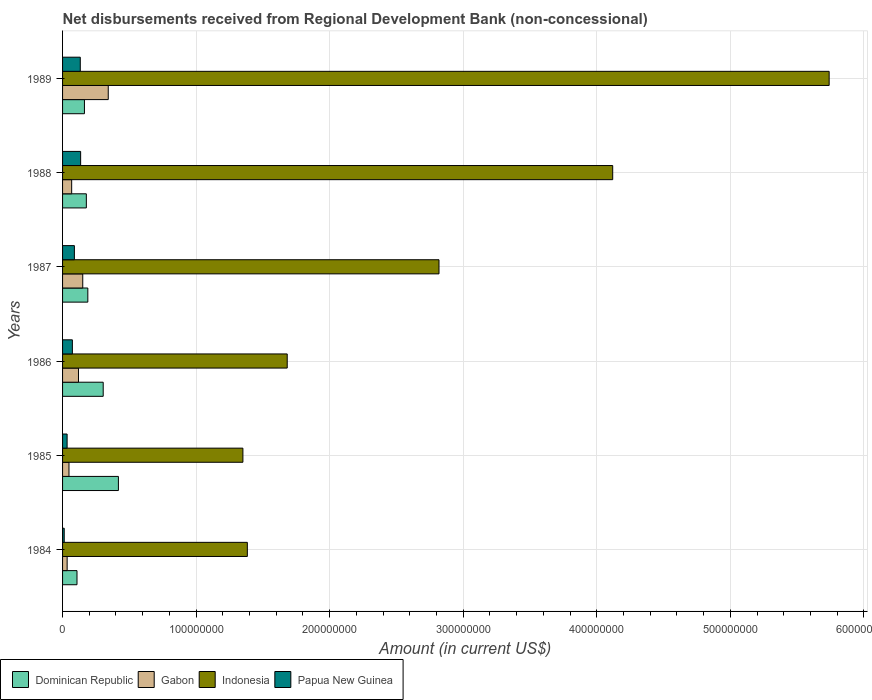How many bars are there on the 1st tick from the top?
Your answer should be compact. 4. How many bars are there on the 1st tick from the bottom?
Your response must be concise. 4. What is the label of the 2nd group of bars from the top?
Your answer should be compact. 1988. What is the amount of disbursements received from Regional Development Bank in Papua New Guinea in 1986?
Your response must be concise. 7.35e+06. Across all years, what is the maximum amount of disbursements received from Regional Development Bank in Dominican Republic?
Ensure brevity in your answer.  4.18e+07. Across all years, what is the minimum amount of disbursements received from Regional Development Bank in Indonesia?
Make the answer very short. 1.35e+08. What is the total amount of disbursements received from Regional Development Bank in Dominican Republic in the graph?
Keep it short and to the point. 1.36e+08. What is the difference between the amount of disbursements received from Regional Development Bank in Dominican Republic in 1985 and that in 1986?
Your answer should be compact. 1.14e+07. What is the difference between the amount of disbursements received from Regional Development Bank in Papua New Guinea in 1987 and the amount of disbursements received from Regional Development Bank in Dominican Republic in 1988?
Provide a succinct answer. -8.96e+06. What is the average amount of disbursements received from Regional Development Bank in Gabon per year?
Your response must be concise. 1.27e+07. In the year 1988, what is the difference between the amount of disbursements received from Regional Development Bank in Gabon and amount of disbursements received from Regional Development Bank in Papua New Guinea?
Give a very brief answer. -6.71e+06. In how many years, is the amount of disbursements received from Regional Development Bank in Dominican Republic greater than 340000000 US$?
Provide a succinct answer. 0. What is the ratio of the amount of disbursements received from Regional Development Bank in Papua New Guinea in 1986 to that in 1989?
Your answer should be very brief. 0.55. What is the difference between the highest and the second highest amount of disbursements received from Regional Development Bank in Gabon?
Provide a succinct answer. 1.91e+07. What is the difference between the highest and the lowest amount of disbursements received from Regional Development Bank in Dominican Republic?
Make the answer very short. 3.10e+07. Is the sum of the amount of disbursements received from Regional Development Bank in Papua New Guinea in 1987 and 1989 greater than the maximum amount of disbursements received from Regional Development Bank in Indonesia across all years?
Keep it short and to the point. No. What does the 4th bar from the top in 1986 represents?
Ensure brevity in your answer.  Dominican Republic. Is it the case that in every year, the sum of the amount of disbursements received from Regional Development Bank in Dominican Republic and amount of disbursements received from Regional Development Bank in Papua New Guinea is greater than the amount of disbursements received from Regional Development Bank in Gabon?
Make the answer very short. No. How many bars are there?
Offer a terse response. 24. How many years are there in the graph?
Provide a short and direct response. 6. Does the graph contain any zero values?
Your answer should be very brief. No. Does the graph contain grids?
Your answer should be very brief. Yes. How many legend labels are there?
Offer a very short reply. 4. How are the legend labels stacked?
Give a very brief answer. Horizontal. What is the title of the graph?
Give a very brief answer. Net disbursements received from Regional Development Bank (non-concessional). What is the label or title of the Y-axis?
Your response must be concise. Years. What is the Amount (in current US$) of Dominican Republic in 1984?
Your answer should be compact. 1.08e+07. What is the Amount (in current US$) of Gabon in 1984?
Offer a terse response. 3.42e+06. What is the Amount (in current US$) of Indonesia in 1984?
Provide a succinct answer. 1.38e+08. What is the Amount (in current US$) in Papua New Guinea in 1984?
Keep it short and to the point. 1.24e+06. What is the Amount (in current US$) in Dominican Republic in 1985?
Your response must be concise. 4.18e+07. What is the Amount (in current US$) in Gabon in 1985?
Your response must be concise. 4.81e+06. What is the Amount (in current US$) of Indonesia in 1985?
Your answer should be very brief. 1.35e+08. What is the Amount (in current US$) in Papua New Guinea in 1985?
Ensure brevity in your answer.  3.40e+06. What is the Amount (in current US$) in Dominican Republic in 1986?
Ensure brevity in your answer.  3.04e+07. What is the Amount (in current US$) in Gabon in 1986?
Offer a very short reply. 1.19e+07. What is the Amount (in current US$) of Indonesia in 1986?
Your answer should be very brief. 1.68e+08. What is the Amount (in current US$) of Papua New Guinea in 1986?
Provide a short and direct response. 7.35e+06. What is the Amount (in current US$) in Dominican Republic in 1987?
Offer a terse response. 1.89e+07. What is the Amount (in current US$) in Gabon in 1987?
Offer a very short reply. 1.51e+07. What is the Amount (in current US$) in Indonesia in 1987?
Ensure brevity in your answer.  2.82e+08. What is the Amount (in current US$) in Papua New Guinea in 1987?
Provide a short and direct response. 8.86e+06. What is the Amount (in current US$) in Dominican Republic in 1988?
Provide a short and direct response. 1.78e+07. What is the Amount (in current US$) of Gabon in 1988?
Offer a very short reply. 6.82e+06. What is the Amount (in current US$) of Indonesia in 1988?
Give a very brief answer. 4.12e+08. What is the Amount (in current US$) in Papua New Guinea in 1988?
Your response must be concise. 1.35e+07. What is the Amount (in current US$) in Dominican Republic in 1989?
Provide a short and direct response. 1.64e+07. What is the Amount (in current US$) of Gabon in 1989?
Keep it short and to the point. 3.42e+07. What is the Amount (in current US$) of Indonesia in 1989?
Your answer should be compact. 5.74e+08. What is the Amount (in current US$) in Papua New Guinea in 1989?
Make the answer very short. 1.33e+07. Across all years, what is the maximum Amount (in current US$) in Dominican Republic?
Give a very brief answer. 4.18e+07. Across all years, what is the maximum Amount (in current US$) in Gabon?
Give a very brief answer. 3.42e+07. Across all years, what is the maximum Amount (in current US$) of Indonesia?
Give a very brief answer. 5.74e+08. Across all years, what is the maximum Amount (in current US$) in Papua New Guinea?
Your response must be concise. 1.35e+07. Across all years, what is the minimum Amount (in current US$) in Dominican Republic?
Provide a succinct answer. 1.08e+07. Across all years, what is the minimum Amount (in current US$) in Gabon?
Offer a very short reply. 3.42e+06. Across all years, what is the minimum Amount (in current US$) in Indonesia?
Your response must be concise. 1.35e+08. Across all years, what is the minimum Amount (in current US$) of Papua New Guinea?
Provide a short and direct response. 1.24e+06. What is the total Amount (in current US$) in Dominican Republic in the graph?
Offer a terse response. 1.36e+08. What is the total Amount (in current US$) of Gabon in the graph?
Offer a very short reply. 7.63e+07. What is the total Amount (in current US$) of Indonesia in the graph?
Provide a succinct answer. 1.71e+09. What is the total Amount (in current US$) of Papua New Guinea in the graph?
Make the answer very short. 4.76e+07. What is the difference between the Amount (in current US$) in Dominican Republic in 1984 and that in 1985?
Offer a terse response. -3.10e+07. What is the difference between the Amount (in current US$) in Gabon in 1984 and that in 1985?
Ensure brevity in your answer.  -1.39e+06. What is the difference between the Amount (in current US$) of Indonesia in 1984 and that in 1985?
Give a very brief answer. 3.32e+06. What is the difference between the Amount (in current US$) of Papua New Guinea in 1984 and that in 1985?
Ensure brevity in your answer.  -2.16e+06. What is the difference between the Amount (in current US$) of Dominican Republic in 1984 and that in 1986?
Offer a very short reply. -1.96e+07. What is the difference between the Amount (in current US$) in Gabon in 1984 and that in 1986?
Your answer should be very brief. -8.49e+06. What is the difference between the Amount (in current US$) in Indonesia in 1984 and that in 1986?
Make the answer very short. -2.99e+07. What is the difference between the Amount (in current US$) of Papua New Guinea in 1984 and that in 1986?
Ensure brevity in your answer.  -6.11e+06. What is the difference between the Amount (in current US$) in Dominican Republic in 1984 and that in 1987?
Make the answer very short. -8.12e+06. What is the difference between the Amount (in current US$) in Gabon in 1984 and that in 1987?
Ensure brevity in your answer.  -1.17e+07. What is the difference between the Amount (in current US$) in Indonesia in 1984 and that in 1987?
Your response must be concise. -1.44e+08. What is the difference between the Amount (in current US$) of Papua New Guinea in 1984 and that in 1987?
Keep it short and to the point. -7.61e+06. What is the difference between the Amount (in current US$) of Dominican Republic in 1984 and that in 1988?
Give a very brief answer. -7.01e+06. What is the difference between the Amount (in current US$) of Gabon in 1984 and that in 1988?
Your response must be concise. -3.39e+06. What is the difference between the Amount (in current US$) in Indonesia in 1984 and that in 1988?
Provide a short and direct response. -2.74e+08. What is the difference between the Amount (in current US$) of Papua New Guinea in 1984 and that in 1988?
Your answer should be compact. -1.23e+07. What is the difference between the Amount (in current US$) in Dominican Republic in 1984 and that in 1989?
Your answer should be compact. -5.57e+06. What is the difference between the Amount (in current US$) of Gabon in 1984 and that in 1989?
Keep it short and to the point. -3.08e+07. What is the difference between the Amount (in current US$) in Indonesia in 1984 and that in 1989?
Offer a very short reply. -4.36e+08. What is the difference between the Amount (in current US$) of Papua New Guinea in 1984 and that in 1989?
Offer a terse response. -1.20e+07. What is the difference between the Amount (in current US$) in Dominican Republic in 1985 and that in 1986?
Your response must be concise. 1.14e+07. What is the difference between the Amount (in current US$) of Gabon in 1985 and that in 1986?
Offer a terse response. -7.11e+06. What is the difference between the Amount (in current US$) of Indonesia in 1985 and that in 1986?
Ensure brevity in your answer.  -3.32e+07. What is the difference between the Amount (in current US$) in Papua New Guinea in 1985 and that in 1986?
Keep it short and to the point. -3.94e+06. What is the difference between the Amount (in current US$) of Dominican Republic in 1985 and that in 1987?
Give a very brief answer. 2.29e+07. What is the difference between the Amount (in current US$) of Gabon in 1985 and that in 1987?
Keep it short and to the point. -1.03e+07. What is the difference between the Amount (in current US$) of Indonesia in 1985 and that in 1987?
Make the answer very short. -1.47e+08. What is the difference between the Amount (in current US$) in Papua New Guinea in 1985 and that in 1987?
Provide a succinct answer. -5.45e+06. What is the difference between the Amount (in current US$) in Dominican Republic in 1985 and that in 1988?
Keep it short and to the point. 2.40e+07. What is the difference between the Amount (in current US$) of Gabon in 1985 and that in 1988?
Give a very brief answer. -2.01e+06. What is the difference between the Amount (in current US$) in Indonesia in 1985 and that in 1988?
Provide a short and direct response. -2.77e+08. What is the difference between the Amount (in current US$) in Papua New Guinea in 1985 and that in 1988?
Offer a very short reply. -1.01e+07. What is the difference between the Amount (in current US$) in Dominican Republic in 1985 and that in 1989?
Keep it short and to the point. 2.54e+07. What is the difference between the Amount (in current US$) of Gabon in 1985 and that in 1989?
Offer a very short reply. -2.94e+07. What is the difference between the Amount (in current US$) in Indonesia in 1985 and that in 1989?
Give a very brief answer. -4.39e+08. What is the difference between the Amount (in current US$) of Papua New Guinea in 1985 and that in 1989?
Provide a short and direct response. -9.86e+06. What is the difference between the Amount (in current US$) in Dominican Republic in 1986 and that in 1987?
Make the answer very short. 1.15e+07. What is the difference between the Amount (in current US$) of Gabon in 1986 and that in 1987?
Keep it short and to the point. -3.20e+06. What is the difference between the Amount (in current US$) of Indonesia in 1986 and that in 1987?
Your answer should be compact. -1.14e+08. What is the difference between the Amount (in current US$) in Papua New Guinea in 1986 and that in 1987?
Ensure brevity in your answer.  -1.51e+06. What is the difference between the Amount (in current US$) in Dominican Republic in 1986 and that in 1988?
Give a very brief answer. 1.26e+07. What is the difference between the Amount (in current US$) in Gabon in 1986 and that in 1988?
Provide a short and direct response. 5.10e+06. What is the difference between the Amount (in current US$) of Indonesia in 1986 and that in 1988?
Make the answer very short. -2.44e+08. What is the difference between the Amount (in current US$) of Papua New Guinea in 1986 and that in 1988?
Offer a terse response. -6.18e+06. What is the difference between the Amount (in current US$) of Dominican Republic in 1986 and that in 1989?
Offer a very short reply. 1.40e+07. What is the difference between the Amount (in current US$) of Gabon in 1986 and that in 1989?
Give a very brief answer. -2.23e+07. What is the difference between the Amount (in current US$) in Indonesia in 1986 and that in 1989?
Your answer should be compact. -4.06e+08. What is the difference between the Amount (in current US$) of Papua New Guinea in 1986 and that in 1989?
Keep it short and to the point. -5.92e+06. What is the difference between the Amount (in current US$) in Dominican Republic in 1987 and that in 1988?
Offer a terse response. 1.11e+06. What is the difference between the Amount (in current US$) in Gabon in 1987 and that in 1988?
Keep it short and to the point. 8.30e+06. What is the difference between the Amount (in current US$) of Indonesia in 1987 and that in 1988?
Your answer should be compact. -1.30e+08. What is the difference between the Amount (in current US$) in Papua New Guinea in 1987 and that in 1988?
Keep it short and to the point. -4.68e+06. What is the difference between the Amount (in current US$) of Dominican Republic in 1987 and that in 1989?
Ensure brevity in your answer.  2.54e+06. What is the difference between the Amount (in current US$) of Gabon in 1987 and that in 1989?
Make the answer very short. -1.91e+07. What is the difference between the Amount (in current US$) of Indonesia in 1987 and that in 1989?
Your answer should be very brief. -2.92e+08. What is the difference between the Amount (in current US$) in Papua New Guinea in 1987 and that in 1989?
Give a very brief answer. -4.41e+06. What is the difference between the Amount (in current US$) of Dominican Republic in 1988 and that in 1989?
Ensure brevity in your answer.  1.43e+06. What is the difference between the Amount (in current US$) of Gabon in 1988 and that in 1989?
Your response must be concise. -2.74e+07. What is the difference between the Amount (in current US$) in Indonesia in 1988 and that in 1989?
Your response must be concise. -1.62e+08. What is the difference between the Amount (in current US$) of Papua New Guinea in 1988 and that in 1989?
Ensure brevity in your answer.  2.67e+05. What is the difference between the Amount (in current US$) in Dominican Republic in 1984 and the Amount (in current US$) in Gabon in 1985?
Your response must be concise. 5.99e+06. What is the difference between the Amount (in current US$) in Dominican Republic in 1984 and the Amount (in current US$) in Indonesia in 1985?
Give a very brief answer. -1.24e+08. What is the difference between the Amount (in current US$) in Dominican Republic in 1984 and the Amount (in current US$) in Papua New Guinea in 1985?
Provide a short and direct response. 7.40e+06. What is the difference between the Amount (in current US$) of Gabon in 1984 and the Amount (in current US$) of Indonesia in 1985?
Make the answer very short. -1.32e+08. What is the difference between the Amount (in current US$) in Gabon in 1984 and the Amount (in current US$) in Papua New Guinea in 1985?
Your response must be concise. 2.10e+04. What is the difference between the Amount (in current US$) of Indonesia in 1984 and the Amount (in current US$) of Papua New Guinea in 1985?
Your answer should be compact. 1.35e+08. What is the difference between the Amount (in current US$) in Dominican Republic in 1984 and the Amount (in current US$) in Gabon in 1986?
Your response must be concise. -1.12e+06. What is the difference between the Amount (in current US$) of Dominican Republic in 1984 and the Amount (in current US$) of Indonesia in 1986?
Give a very brief answer. -1.57e+08. What is the difference between the Amount (in current US$) in Dominican Republic in 1984 and the Amount (in current US$) in Papua New Guinea in 1986?
Make the answer very short. 3.46e+06. What is the difference between the Amount (in current US$) of Gabon in 1984 and the Amount (in current US$) of Indonesia in 1986?
Your answer should be compact. -1.65e+08. What is the difference between the Amount (in current US$) of Gabon in 1984 and the Amount (in current US$) of Papua New Guinea in 1986?
Your answer should be compact. -3.92e+06. What is the difference between the Amount (in current US$) of Indonesia in 1984 and the Amount (in current US$) of Papua New Guinea in 1986?
Your answer should be compact. 1.31e+08. What is the difference between the Amount (in current US$) in Dominican Republic in 1984 and the Amount (in current US$) in Gabon in 1987?
Your answer should be very brief. -4.32e+06. What is the difference between the Amount (in current US$) in Dominican Republic in 1984 and the Amount (in current US$) in Indonesia in 1987?
Your response must be concise. -2.71e+08. What is the difference between the Amount (in current US$) of Dominican Republic in 1984 and the Amount (in current US$) of Papua New Guinea in 1987?
Provide a short and direct response. 1.95e+06. What is the difference between the Amount (in current US$) of Gabon in 1984 and the Amount (in current US$) of Indonesia in 1987?
Your answer should be very brief. -2.78e+08. What is the difference between the Amount (in current US$) of Gabon in 1984 and the Amount (in current US$) of Papua New Guinea in 1987?
Provide a succinct answer. -5.43e+06. What is the difference between the Amount (in current US$) of Indonesia in 1984 and the Amount (in current US$) of Papua New Guinea in 1987?
Provide a short and direct response. 1.30e+08. What is the difference between the Amount (in current US$) of Dominican Republic in 1984 and the Amount (in current US$) of Gabon in 1988?
Your answer should be very brief. 3.98e+06. What is the difference between the Amount (in current US$) in Dominican Republic in 1984 and the Amount (in current US$) in Indonesia in 1988?
Provide a short and direct response. -4.01e+08. What is the difference between the Amount (in current US$) of Dominican Republic in 1984 and the Amount (in current US$) of Papua New Guinea in 1988?
Offer a very short reply. -2.73e+06. What is the difference between the Amount (in current US$) in Gabon in 1984 and the Amount (in current US$) in Indonesia in 1988?
Ensure brevity in your answer.  -4.09e+08. What is the difference between the Amount (in current US$) of Gabon in 1984 and the Amount (in current US$) of Papua New Guinea in 1988?
Offer a terse response. -1.01e+07. What is the difference between the Amount (in current US$) of Indonesia in 1984 and the Amount (in current US$) of Papua New Guinea in 1988?
Make the answer very short. 1.25e+08. What is the difference between the Amount (in current US$) of Dominican Republic in 1984 and the Amount (in current US$) of Gabon in 1989?
Ensure brevity in your answer.  -2.34e+07. What is the difference between the Amount (in current US$) in Dominican Republic in 1984 and the Amount (in current US$) in Indonesia in 1989?
Keep it short and to the point. -5.63e+08. What is the difference between the Amount (in current US$) in Dominican Republic in 1984 and the Amount (in current US$) in Papua New Guinea in 1989?
Provide a short and direct response. -2.46e+06. What is the difference between the Amount (in current US$) of Gabon in 1984 and the Amount (in current US$) of Indonesia in 1989?
Your response must be concise. -5.71e+08. What is the difference between the Amount (in current US$) of Gabon in 1984 and the Amount (in current US$) of Papua New Guinea in 1989?
Keep it short and to the point. -9.84e+06. What is the difference between the Amount (in current US$) of Indonesia in 1984 and the Amount (in current US$) of Papua New Guinea in 1989?
Offer a terse response. 1.25e+08. What is the difference between the Amount (in current US$) in Dominican Republic in 1985 and the Amount (in current US$) in Gabon in 1986?
Your response must be concise. 2.99e+07. What is the difference between the Amount (in current US$) of Dominican Republic in 1985 and the Amount (in current US$) of Indonesia in 1986?
Ensure brevity in your answer.  -1.26e+08. What is the difference between the Amount (in current US$) in Dominican Republic in 1985 and the Amount (in current US$) in Papua New Guinea in 1986?
Make the answer very short. 3.45e+07. What is the difference between the Amount (in current US$) of Gabon in 1985 and the Amount (in current US$) of Indonesia in 1986?
Make the answer very short. -1.63e+08. What is the difference between the Amount (in current US$) of Gabon in 1985 and the Amount (in current US$) of Papua New Guinea in 1986?
Ensure brevity in your answer.  -2.54e+06. What is the difference between the Amount (in current US$) of Indonesia in 1985 and the Amount (in current US$) of Papua New Guinea in 1986?
Offer a very short reply. 1.28e+08. What is the difference between the Amount (in current US$) of Dominican Republic in 1985 and the Amount (in current US$) of Gabon in 1987?
Ensure brevity in your answer.  2.67e+07. What is the difference between the Amount (in current US$) in Dominican Republic in 1985 and the Amount (in current US$) in Indonesia in 1987?
Offer a very short reply. -2.40e+08. What is the difference between the Amount (in current US$) in Dominican Republic in 1985 and the Amount (in current US$) in Papua New Guinea in 1987?
Give a very brief answer. 3.30e+07. What is the difference between the Amount (in current US$) in Gabon in 1985 and the Amount (in current US$) in Indonesia in 1987?
Your response must be concise. -2.77e+08. What is the difference between the Amount (in current US$) of Gabon in 1985 and the Amount (in current US$) of Papua New Guinea in 1987?
Your answer should be very brief. -4.04e+06. What is the difference between the Amount (in current US$) in Indonesia in 1985 and the Amount (in current US$) in Papua New Guinea in 1987?
Make the answer very short. 1.26e+08. What is the difference between the Amount (in current US$) of Dominican Republic in 1985 and the Amount (in current US$) of Gabon in 1988?
Your answer should be compact. 3.50e+07. What is the difference between the Amount (in current US$) in Dominican Republic in 1985 and the Amount (in current US$) in Indonesia in 1988?
Your answer should be compact. -3.70e+08. What is the difference between the Amount (in current US$) of Dominican Republic in 1985 and the Amount (in current US$) of Papua New Guinea in 1988?
Make the answer very short. 2.83e+07. What is the difference between the Amount (in current US$) in Gabon in 1985 and the Amount (in current US$) in Indonesia in 1988?
Your answer should be very brief. -4.07e+08. What is the difference between the Amount (in current US$) of Gabon in 1985 and the Amount (in current US$) of Papua New Guinea in 1988?
Ensure brevity in your answer.  -8.72e+06. What is the difference between the Amount (in current US$) in Indonesia in 1985 and the Amount (in current US$) in Papua New Guinea in 1988?
Your answer should be compact. 1.22e+08. What is the difference between the Amount (in current US$) in Dominican Republic in 1985 and the Amount (in current US$) in Gabon in 1989?
Make the answer very short. 7.61e+06. What is the difference between the Amount (in current US$) of Dominican Republic in 1985 and the Amount (in current US$) of Indonesia in 1989?
Provide a succinct answer. -5.32e+08. What is the difference between the Amount (in current US$) of Dominican Republic in 1985 and the Amount (in current US$) of Papua New Guinea in 1989?
Ensure brevity in your answer.  2.86e+07. What is the difference between the Amount (in current US$) in Gabon in 1985 and the Amount (in current US$) in Indonesia in 1989?
Provide a short and direct response. -5.69e+08. What is the difference between the Amount (in current US$) of Gabon in 1985 and the Amount (in current US$) of Papua New Guinea in 1989?
Your response must be concise. -8.45e+06. What is the difference between the Amount (in current US$) in Indonesia in 1985 and the Amount (in current US$) in Papua New Guinea in 1989?
Keep it short and to the point. 1.22e+08. What is the difference between the Amount (in current US$) in Dominican Republic in 1986 and the Amount (in current US$) in Gabon in 1987?
Offer a very short reply. 1.53e+07. What is the difference between the Amount (in current US$) in Dominican Republic in 1986 and the Amount (in current US$) in Indonesia in 1987?
Make the answer very short. -2.51e+08. What is the difference between the Amount (in current US$) of Dominican Republic in 1986 and the Amount (in current US$) of Papua New Guinea in 1987?
Offer a terse response. 2.16e+07. What is the difference between the Amount (in current US$) of Gabon in 1986 and the Amount (in current US$) of Indonesia in 1987?
Offer a terse response. -2.70e+08. What is the difference between the Amount (in current US$) of Gabon in 1986 and the Amount (in current US$) of Papua New Guinea in 1987?
Ensure brevity in your answer.  3.06e+06. What is the difference between the Amount (in current US$) in Indonesia in 1986 and the Amount (in current US$) in Papua New Guinea in 1987?
Provide a succinct answer. 1.59e+08. What is the difference between the Amount (in current US$) in Dominican Republic in 1986 and the Amount (in current US$) in Gabon in 1988?
Ensure brevity in your answer.  2.36e+07. What is the difference between the Amount (in current US$) in Dominican Republic in 1986 and the Amount (in current US$) in Indonesia in 1988?
Provide a succinct answer. -3.82e+08. What is the difference between the Amount (in current US$) of Dominican Republic in 1986 and the Amount (in current US$) of Papua New Guinea in 1988?
Your answer should be very brief. 1.69e+07. What is the difference between the Amount (in current US$) of Gabon in 1986 and the Amount (in current US$) of Indonesia in 1988?
Keep it short and to the point. -4.00e+08. What is the difference between the Amount (in current US$) of Gabon in 1986 and the Amount (in current US$) of Papua New Guinea in 1988?
Give a very brief answer. -1.61e+06. What is the difference between the Amount (in current US$) in Indonesia in 1986 and the Amount (in current US$) in Papua New Guinea in 1988?
Provide a succinct answer. 1.55e+08. What is the difference between the Amount (in current US$) of Dominican Republic in 1986 and the Amount (in current US$) of Gabon in 1989?
Provide a succinct answer. -3.79e+06. What is the difference between the Amount (in current US$) of Dominican Republic in 1986 and the Amount (in current US$) of Indonesia in 1989?
Offer a very short reply. -5.44e+08. What is the difference between the Amount (in current US$) in Dominican Republic in 1986 and the Amount (in current US$) in Papua New Guinea in 1989?
Offer a very short reply. 1.72e+07. What is the difference between the Amount (in current US$) of Gabon in 1986 and the Amount (in current US$) of Indonesia in 1989?
Provide a short and direct response. -5.62e+08. What is the difference between the Amount (in current US$) in Gabon in 1986 and the Amount (in current US$) in Papua New Guinea in 1989?
Offer a very short reply. -1.35e+06. What is the difference between the Amount (in current US$) of Indonesia in 1986 and the Amount (in current US$) of Papua New Guinea in 1989?
Ensure brevity in your answer.  1.55e+08. What is the difference between the Amount (in current US$) of Dominican Republic in 1987 and the Amount (in current US$) of Gabon in 1988?
Provide a short and direct response. 1.21e+07. What is the difference between the Amount (in current US$) of Dominican Republic in 1987 and the Amount (in current US$) of Indonesia in 1988?
Your response must be concise. -3.93e+08. What is the difference between the Amount (in current US$) in Dominican Republic in 1987 and the Amount (in current US$) in Papua New Guinea in 1988?
Your answer should be compact. 5.39e+06. What is the difference between the Amount (in current US$) of Gabon in 1987 and the Amount (in current US$) of Indonesia in 1988?
Your response must be concise. -3.97e+08. What is the difference between the Amount (in current US$) in Gabon in 1987 and the Amount (in current US$) in Papua New Guinea in 1988?
Keep it short and to the point. 1.59e+06. What is the difference between the Amount (in current US$) of Indonesia in 1987 and the Amount (in current US$) of Papua New Guinea in 1988?
Your answer should be compact. 2.68e+08. What is the difference between the Amount (in current US$) of Dominican Republic in 1987 and the Amount (in current US$) of Gabon in 1989?
Keep it short and to the point. -1.53e+07. What is the difference between the Amount (in current US$) of Dominican Republic in 1987 and the Amount (in current US$) of Indonesia in 1989?
Provide a succinct answer. -5.55e+08. What is the difference between the Amount (in current US$) in Dominican Republic in 1987 and the Amount (in current US$) in Papua New Guinea in 1989?
Provide a succinct answer. 5.66e+06. What is the difference between the Amount (in current US$) in Gabon in 1987 and the Amount (in current US$) in Indonesia in 1989?
Offer a very short reply. -5.59e+08. What is the difference between the Amount (in current US$) of Gabon in 1987 and the Amount (in current US$) of Papua New Guinea in 1989?
Make the answer very short. 1.85e+06. What is the difference between the Amount (in current US$) of Indonesia in 1987 and the Amount (in current US$) of Papua New Guinea in 1989?
Keep it short and to the point. 2.69e+08. What is the difference between the Amount (in current US$) in Dominican Republic in 1988 and the Amount (in current US$) in Gabon in 1989?
Offer a very short reply. -1.64e+07. What is the difference between the Amount (in current US$) in Dominican Republic in 1988 and the Amount (in current US$) in Indonesia in 1989?
Ensure brevity in your answer.  -5.56e+08. What is the difference between the Amount (in current US$) in Dominican Republic in 1988 and the Amount (in current US$) in Papua New Guinea in 1989?
Offer a terse response. 4.54e+06. What is the difference between the Amount (in current US$) of Gabon in 1988 and the Amount (in current US$) of Indonesia in 1989?
Provide a succinct answer. -5.67e+08. What is the difference between the Amount (in current US$) of Gabon in 1988 and the Amount (in current US$) of Papua New Guinea in 1989?
Ensure brevity in your answer.  -6.45e+06. What is the difference between the Amount (in current US$) of Indonesia in 1988 and the Amount (in current US$) of Papua New Guinea in 1989?
Give a very brief answer. 3.99e+08. What is the average Amount (in current US$) in Dominican Republic per year?
Keep it short and to the point. 2.27e+07. What is the average Amount (in current US$) of Gabon per year?
Keep it short and to the point. 1.27e+07. What is the average Amount (in current US$) of Indonesia per year?
Provide a short and direct response. 2.85e+08. What is the average Amount (in current US$) in Papua New Guinea per year?
Ensure brevity in your answer.  7.94e+06. In the year 1984, what is the difference between the Amount (in current US$) of Dominican Republic and Amount (in current US$) of Gabon?
Your response must be concise. 7.38e+06. In the year 1984, what is the difference between the Amount (in current US$) of Dominican Republic and Amount (in current US$) of Indonesia?
Your answer should be very brief. -1.28e+08. In the year 1984, what is the difference between the Amount (in current US$) of Dominican Republic and Amount (in current US$) of Papua New Guinea?
Provide a short and direct response. 9.56e+06. In the year 1984, what is the difference between the Amount (in current US$) in Gabon and Amount (in current US$) in Indonesia?
Your answer should be very brief. -1.35e+08. In the year 1984, what is the difference between the Amount (in current US$) in Gabon and Amount (in current US$) in Papua New Guinea?
Make the answer very short. 2.18e+06. In the year 1984, what is the difference between the Amount (in current US$) of Indonesia and Amount (in current US$) of Papua New Guinea?
Offer a terse response. 1.37e+08. In the year 1985, what is the difference between the Amount (in current US$) in Dominican Republic and Amount (in current US$) in Gabon?
Your answer should be compact. 3.70e+07. In the year 1985, what is the difference between the Amount (in current US$) of Dominican Republic and Amount (in current US$) of Indonesia?
Your answer should be very brief. -9.32e+07. In the year 1985, what is the difference between the Amount (in current US$) of Dominican Republic and Amount (in current US$) of Papua New Guinea?
Make the answer very short. 3.84e+07. In the year 1985, what is the difference between the Amount (in current US$) of Gabon and Amount (in current US$) of Indonesia?
Your answer should be compact. -1.30e+08. In the year 1985, what is the difference between the Amount (in current US$) of Gabon and Amount (in current US$) of Papua New Guinea?
Keep it short and to the point. 1.41e+06. In the year 1985, what is the difference between the Amount (in current US$) of Indonesia and Amount (in current US$) of Papua New Guinea?
Provide a short and direct response. 1.32e+08. In the year 1986, what is the difference between the Amount (in current US$) in Dominican Republic and Amount (in current US$) in Gabon?
Offer a very short reply. 1.85e+07. In the year 1986, what is the difference between the Amount (in current US$) in Dominican Republic and Amount (in current US$) in Indonesia?
Offer a terse response. -1.38e+08. In the year 1986, what is the difference between the Amount (in current US$) of Dominican Republic and Amount (in current US$) of Papua New Guinea?
Provide a succinct answer. 2.31e+07. In the year 1986, what is the difference between the Amount (in current US$) in Gabon and Amount (in current US$) in Indonesia?
Offer a very short reply. -1.56e+08. In the year 1986, what is the difference between the Amount (in current US$) of Gabon and Amount (in current US$) of Papua New Guinea?
Provide a short and direct response. 4.57e+06. In the year 1986, what is the difference between the Amount (in current US$) of Indonesia and Amount (in current US$) of Papua New Guinea?
Your answer should be very brief. 1.61e+08. In the year 1987, what is the difference between the Amount (in current US$) in Dominican Republic and Amount (in current US$) in Gabon?
Your answer should be compact. 3.80e+06. In the year 1987, what is the difference between the Amount (in current US$) of Dominican Republic and Amount (in current US$) of Indonesia?
Provide a succinct answer. -2.63e+08. In the year 1987, what is the difference between the Amount (in current US$) of Dominican Republic and Amount (in current US$) of Papua New Guinea?
Your response must be concise. 1.01e+07. In the year 1987, what is the difference between the Amount (in current US$) of Gabon and Amount (in current US$) of Indonesia?
Offer a very short reply. -2.67e+08. In the year 1987, what is the difference between the Amount (in current US$) of Gabon and Amount (in current US$) of Papua New Guinea?
Offer a very short reply. 6.26e+06. In the year 1987, what is the difference between the Amount (in current US$) of Indonesia and Amount (in current US$) of Papua New Guinea?
Ensure brevity in your answer.  2.73e+08. In the year 1988, what is the difference between the Amount (in current US$) in Dominican Republic and Amount (in current US$) in Gabon?
Provide a short and direct response. 1.10e+07. In the year 1988, what is the difference between the Amount (in current US$) of Dominican Republic and Amount (in current US$) of Indonesia?
Your answer should be compact. -3.94e+08. In the year 1988, what is the difference between the Amount (in current US$) in Dominican Republic and Amount (in current US$) in Papua New Guinea?
Provide a short and direct response. 4.28e+06. In the year 1988, what is the difference between the Amount (in current US$) in Gabon and Amount (in current US$) in Indonesia?
Ensure brevity in your answer.  -4.05e+08. In the year 1988, what is the difference between the Amount (in current US$) in Gabon and Amount (in current US$) in Papua New Guinea?
Make the answer very short. -6.71e+06. In the year 1988, what is the difference between the Amount (in current US$) in Indonesia and Amount (in current US$) in Papua New Guinea?
Give a very brief answer. 3.98e+08. In the year 1989, what is the difference between the Amount (in current US$) of Dominican Republic and Amount (in current US$) of Gabon?
Provide a short and direct response. -1.78e+07. In the year 1989, what is the difference between the Amount (in current US$) of Dominican Republic and Amount (in current US$) of Indonesia?
Your answer should be very brief. -5.58e+08. In the year 1989, what is the difference between the Amount (in current US$) in Dominican Republic and Amount (in current US$) in Papua New Guinea?
Your response must be concise. 3.11e+06. In the year 1989, what is the difference between the Amount (in current US$) in Gabon and Amount (in current US$) in Indonesia?
Your answer should be compact. -5.40e+08. In the year 1989, what is the difference between the Amount (in current US$) in Gabon and Amount (in current US$) in Papua New Guinea?
Your response must be concise. 2.09e+07. In the year 1989, what is the difference between the Amount (in current US$) of Indonesia and Amount (in current US$) of Papua New Guinea?
Keep it short and to the point. 5.61e+08. What is the ratio of the Amount (in current US$) of Dominican Republic in 1984 to that in 1985?
Ensure brevity in your answer.  0.26. What is the ratio of the Amount (in current US$) in Gabon in 1984 to that in 1985?
Your response must be concise. 0.71. What is the ratio of the Amount (in current US$) of Indonesia in 1984 to that in 1985?
Give a very brief answer. 1.02. What is the ratio of the Amount (in current US$) in Papua New Guinea in 1984 to that in 1985?
Your response must be concise. 0.36. What is the ratio of the Amount (in current US$) in Dominican Republic in 1984 to that in 1986?
Give a very brief answer. 0.36. What is the ratio of the Amount (in current US$) in Gabon in 1984 to that in 1986?
Provide a succinct answer. 0.29. What is the ratio of the Amount (in current US$) in Indonesia in 1984 to that in 1986?
Offer a very short reply. 0.82. What is the ratio of the Amount (in current US$) of Papua New Guinea in 1984 to that in 1986?
Give a very brief answer. 0.17. What is the ratio of the Amount (in current US$) of Dominican Republic in 1984 to that in 1987?
Your response must be concise. 0.57. What is the ratio of the Amount (in current US$) in Gabon in 1984 to that in 1987?
Keep it short and to the point. 0.23. What is the ratio of the Amount (in current US$) of Indonesia in 1984 to that in 1987?
Provide a short and direct response. 0.49. What is the ratio of the Amount (in current US$) of Papua New Guinea in 1984 to that in 1987?
Keep it short and to the point. 0.14. What is the ratio of the Amount (in current US$) in Dominican Republic in 1984 to that in 1988?
Offer a very short reply. 0.61. What is the ratio of the Amount (in current US$) in Gabon in 1984 to that in 1988?
Give a very brief answer. 0.5. What is the ratio of the Amount (in current US$) of Indonesia in 1984 to that in 1988?
Your response must be concise. 0.34. What is the ratio of the Amount (in current US$) of Papua New Guinea in 1984 to that in 1988?
Offer a terse response. 0.09. What is the ratio of the Amount (in current US$) of Dominican Republic in 1984 to that in 1989?
Give a very brief answer. 0.66. What is the ratio of the Amount (in current US$) of Gabon in 1984 to that in 1989?
Make the answer very short. 0.1. What is the ratio of the Amount (in current US$) in Indonesia in 1984 to that in 1989?
Ensure brevity in your answer.  0.24. What is the ratio of the Amount (in current US$) in Papua New Guinea in 1984 to that in 1989?
Your answer should be compact. 0.09. What is the ratio of the Amount (in current US$) of Dominican Republic in 1985 to that in 1986?
Give a very brief answer. 1.37. What is the ratio of the Amount (in current US$) in Gabon in 1985 to that in 1986?
Your answer should be very brief. 0.4. What is the ratio of the Amount (in current US$) of Indonesia in 1985 to that in 1986?
Your response must be concise. 0.8. What is the ratio of the Amount (in current US$) of Papua New Guinea in 1985 to that in 1986?
Provide a short and direct response. 0.46. What is the ratio of the Amount (in current US$) in Dominican Republic in 1985 to that in 1987?
Your answer should be very brief. 2.21. What is the ratio of the Amount (in current US$) in Gabon in 1985 to that in 1987?
Your answer should be compact. 0.32. What is the ratio of the Amount (in current US$) of Indonesia in 1985 to that in 1987?
Offer a very short reply. 0.48. What is the ratio of the Amount (in current US$) in Papua New Guinea in 1985 to that in 1987?
Offer a very short reply. 0.38. What is the ratio of the Amount (in current US$) of Dominican Republic in 1985 to that in 1988?
Ensure brevity in your answer.  2.35. What is the ratio of the Amount (in current US$) of Gabon in 1985 to that in 1988?
Your answer should be compact. 0.71. What is the ratio of the Amount (in current US$) of Indonesia in 1985 to that in 1988?
Your response must be concise. 0.33. What is the ratio of the Amount (in current US$) in Papua New Guinea in 1985 to that in 1988?
Keep it short and to the point. 0.25. What is the ratio of the Amount (in current US$) in Dominican Republic in 1985 to that in 1989?
Provide a short and direct response. 2.55. What is the ratio of the Amount (in current US$) of Gabon in 1985 to that in 1989?
Your answer should be compact. 0.14. What is the ratio of the Amount (in current US$) in Indonesia in 1985 to that in 1989?
Your answer should be very brief. 0.24. What is the ratio of the Amount (in current US$) of Papua New Guinea in 1985 to that in 1989?
Keep it short and to the point. 0.26. What is the ratio of the Amount (in current US$) in Dominican Republic in 1986 to that in 1987?
Make the answer very short. 1.61. What is the ratio of the Amount (in current US$) of Gabon in 1986 to that in 1987?
Your answer should be very brief. 0.79. What is the ratio of the Amount (in current US$) of Indonesia in 1986 to that in 1987?
Provide a succinct answer. 0.6. What is the ratio of the Amount (in current US$) of Papua New Guinea in 1986 to that in 1987?
Make the answer very short. 0.83. What is the ratio of the Amount (in current US$) in Dominican Republic in 1986 to that in 1988?
Ensure brevity in your answer.  1.71. What is the ratio of the Amount (in current US$) of Gabon in 1986 to that in 1988?
Make the answer very short. 1.75. What is the ratio of the Amount (in current US$) in Indonesia in 1986 to that in 1988?
Offer a very short reply. 0.41. What is the ratio of the Amount (in current US$) of Papua New Guinea in 1986 to that in 1988?
Ensure brevity in your answer.  0.54. What is the ratio of the Amount (in current US$) of Dominican Republic in 1986 to that in 1989?
Offer a terse response. 1.86. What is the ratio of the Amount (in current US$) of Gabon in 1986 to that in 1989?
Offer a very short reply. 0.35. What is the ratio of the Amount (in current US$) of Indonesia in 1986 to that in 1989?
Provide a succinct answer. 0.29. What is the ratio of the Amount (in current US$) of Papua New Guinea in 1986 to that in 1989?
Keep it short and to the point. 0.55. What is the ratio of the Amount (in current US$) of Dominican Republic in 1987 to that in 1988?
Your response must be concise. 1.06. What is the ratio of the Amount (in current US$) of Gabon in 1987 to that in 1988?
Make the answer very short. 2.22. What is the ratio of the Amount (in current US$) in Indonesia in 1987 to that in 1988?
Provide a short and direct response. 0.68. What is the ratio of the Amount (in current US$) in Papua New Guinea in 1987 to that in 1988?
Keep it short and to the point. 0.65. What is the ratio of the Amount (in current US$) in Dominican Republic in 1987 to that in 1989?
Ensure brevity in your answer.  1.16. What is the ratio of the Amount (in current US$) in Gabon in 1987 to that in 1989?
Ensure brevity in your answer.  0.44. What is the ratio of the Amount (in current US$) in Indonesia in 1987 to that in 1989?
Make the answer very short. 0.49. What is the ratio of the Amount (in current US$) of Papua New Guinea in 1987 to that in 1989?
Your response must be concise. 0.67. What is the ratio of the Amount (in current US$) in Dominican Republic in 1988 to that in 1989?
Provide a succinct answer. 1.09. What is the ratio of the Amount (in current US$) in Gabon in 1988 to that in 1989?
Make the answer very short. 0.2. What is the ratio of the Amount (in current US$) in Indonesia in 1988 to that in 1989?
Ensure brevity in your answer.  0.72. What is the ratio of the Amount (in current US$) in Papua New Guinea in 1988 to that in 1989?
Provide a succinct answer. 1.02. What is the difference between the highest and the second highest Amount (in current US$) of Dominican Republic?
Provide a short and direct response. 1.14e+07. What is the difference between the highest and the second highest Amount (in current US$) of Gabon?
Make the answer very short. 1.91e+07. What is the difference between the highest and the second highest Amount (in current US$) in Indonesia?
Provide a succinct answer. 1.62e+08. What is the difference between the highest and the second highest Amount (in current US$) of Papua New Guinea?
Offer a very short reply. 2.67e+05. What is the difference between the highest and the lowest Amount (in current US$) in Dominican Republic?
Keep it short and to the point. 3.10e+07. What is the difference between the highest and the lowest Amount (in current US$) of Gabon?
Offer a terse response. 3.08e+07. What is the difference between the highest and the lowest Amount (in current US$) in Indonesia?
Your answer should be compact. 4.39e+08. What is the difference between the highest and the lowest Amount (in current US$) of Papua New Guinea?
Make the answer very short. 1.23e+07. 